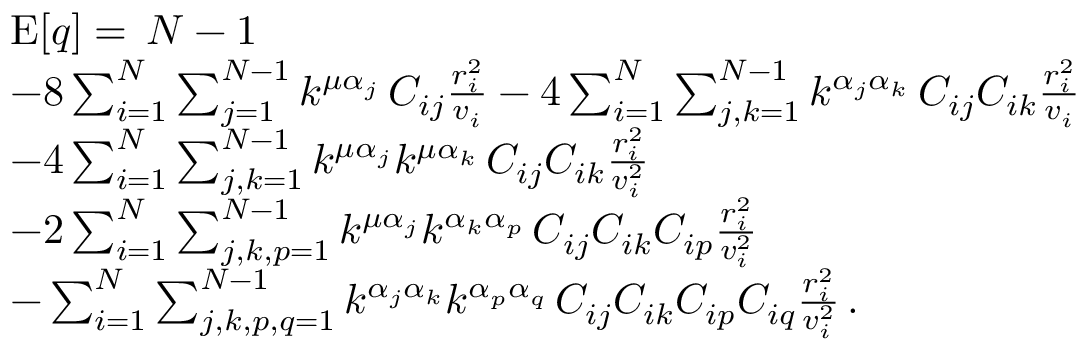<formula> <loc_0><loc_0><loc_500><loc_500>\begin{array} { r l } & { E [ q ] = \, N - 1 } \\ & { - 8 \sum _ { i = 1 } ^ { N } \sum _ { j = 1 } ^ { N - 1 } k ^ { \mu \alpha _ { j } } \, C _ { i j } \frac { r _ { i } ^ { 2 } } { v _ { i } } - 4 \sum _ { i = 1 } ^ { N } \sum _ { j , k = 1 } ^ { N - 1 } k ^ { \alpha _ { j } \alpha _ { k } } \, C _ { i j } C _ { i k } \frac { r _ { i } ^ { 2 } } { v _ { i } } } \\ & { - 4 \sum _ { i = 1 } ^ { N } \sum _ { j , k = 1 } ^ { N - 1 } k ^ { \mu \alpha _ { j } } k ^ { \mu \alpha _ { k } } \, C _ { i j } C _ { i k } \frac { r _ { i } ^ { 2 } } { v _ { i } ^ { 2 } } } \\ & { - 2 \sum _ { i = 1 } ^ { N } \sum _ { j , k , p = 1 } ^ { N - 1 } k ^ { \mu \alpha _ { j } } k ^ { \alpha _ { k } \alpha _ { p } } \, C _ { i j } C _ { i k } C _ { i p } \frac { r _ { i } ^ { 2 } } { v _ { i } ^ { 2 } } } \\ & { - \sum _ { i = 1 } ^ { N } \sum _ { j , k , p , q = 1 } ^ { N - 1 } k ^ { \alpha _ { j } \alpha _ { k } } k ^ { \alpha _ { p } \alpha _ { q } } \, C _ { i j } C _ { i k } C _ { i p } C _ { i q } \frac { r _ { i } ^ { 2 } } { v _ { i } ^ { 2 } } \, . } \end{array}</formula> 